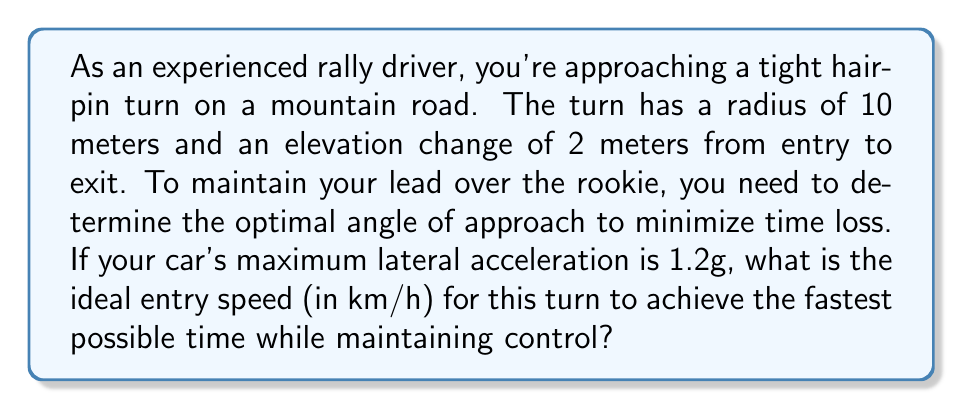Solve this math problem. To solve this problem, we need to consider several factors:

1. The geometry of the turn
2. The maximum lateral acceleration of the car
3. The relationship between speed, radius, and lateral acceleration

Let's approach this step-by-step:

1. First, we need to calculate the effective radius of the turn, considering the elevation change:

   $$R_{effective} = \sqrt{R^2 + (\Delta h)^2} = \sqrt{10^2 + 2^2} = \sqrt{104} \approx 10.2 \text{ meters}$$

2. The maximum lateral acceleration is given as 1.2g. We need to convert this to m/s²:

   $$a_{lateral} = 1.2 \times 9.81 = 11.772 \text{ m/s²}$$

3. Now, we can use the formula relating velocity, radius, and acceleration:

   $$a = \frac{v^2}{r}$$

   Rearranging for velocity:

   $$v = \sqrt{a \times r}$$

4. Plugging in our values:

   $$v = \sqrt{11.772 \times 10.2} = \sqrt{120.0744} \approx 10.96 \text{ m/s}$$

5. Convert this speed to km/h:

   $$10.96 \text{ m/s} \times \frac{3600 \text{ s}}{1 \text{ hour}} \times \frac{1 \text{ km}}{1000 \text{ m}} \approx 39.46 \text{ km/h}$$

This speed represents the maximum entry speed that allows you to maintain the tightest possible line through the turn without losing control, thus minimizing time loss.

[asy]
import geometry;

size(200);
pair O = (0,0);
real r = 5;
path c = circle(O, r);
draw(c);
draw((-6,0)--(6,0), arrow=Arrow(TeXHead));
draw((0,-6)--(0,6), arrow=Arrow(TeXHead));
label("10m radius", (3,-5));
draw((5,0)--(5,1), arrow=Arrow(TeXHead));
label("2m elevation", (6,0.5));
draw((-7,-2)--(0,0), arrow=Arrow(TeXHead));
label("Entry", (-5,-1.5));
draw((0,0)--(7,2), arrow=Arrow(TeXHead));
label("Exit", (5,1.5));
[/asy]
Answer: The ideal entry speed for the hairpin turn to minimize time loss while maintaining control is approximately 39.5 km/h. 